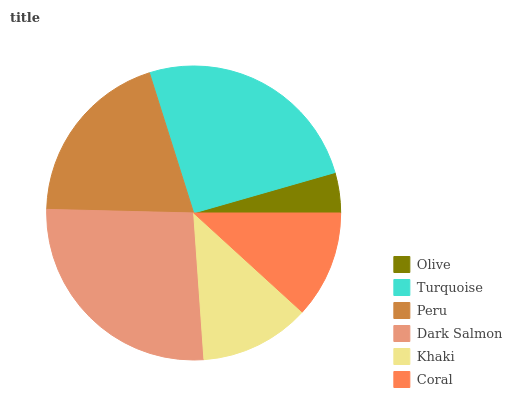Is Olive the minimum?
Answer yes or no. Yes. Is Dark Salmon the maximum?
Answer yes or no. Yes. Is Turquoise the minimum?
Answer yes or no. No. Is Turquoise the maximum?
Answer yes or no. No. Is Turquoise greater than Olive?
Answer yes or no. Yes. Is Olive less than Turquoise?
Answer yes or no. Yes. Is Olive greater than Turquoise?
Answer yes or no. No. Is Turquoise less than Olive?
Answer yes or no. No. Is Peru the high median?
Answer yes or no. Yes. Is Khaki the low median?
Answer yes or no. Yes. Is Coral the high median?
Answer yes or no. No. Is Peru the low median?
Answer yes or no. No. 